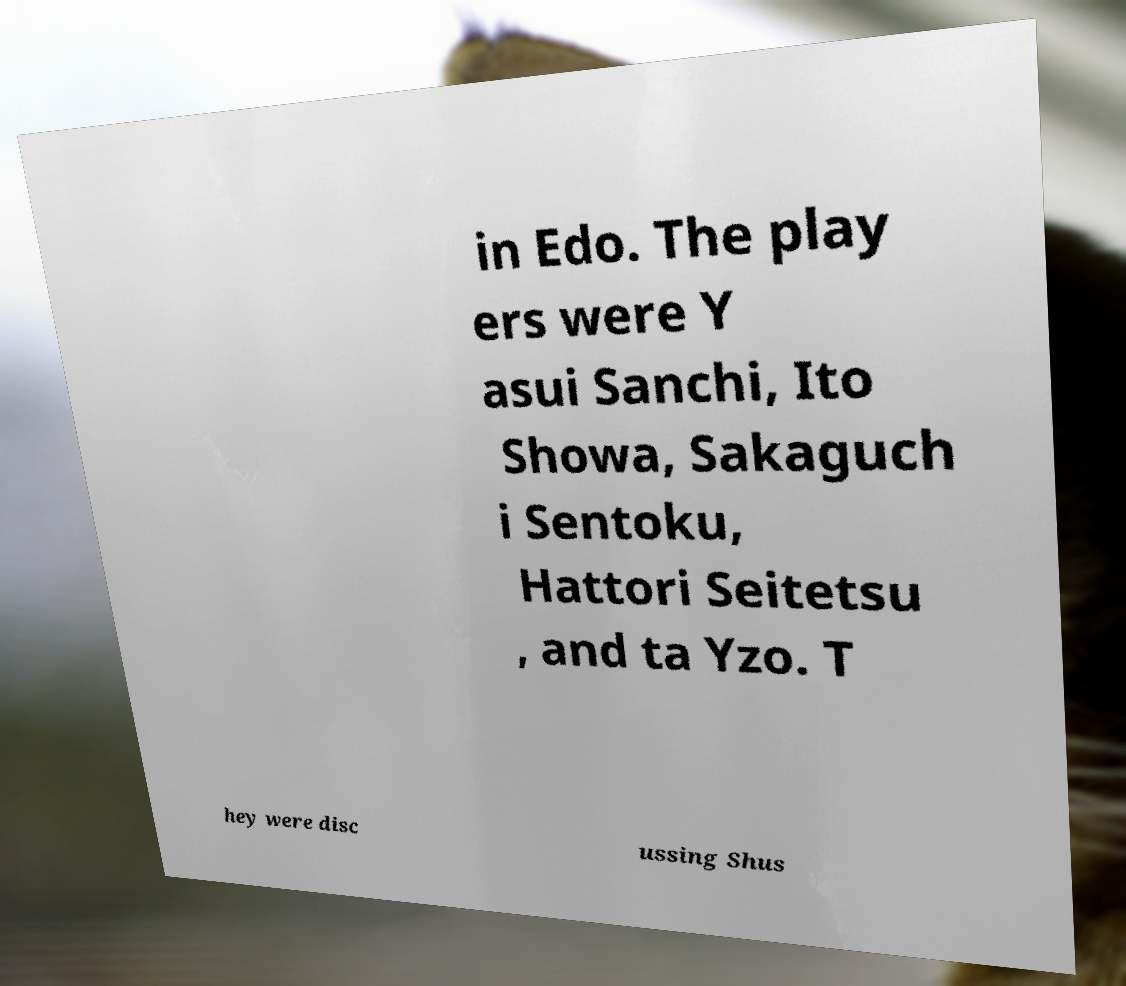Could you assist in decoding the text presented in this image and type it out clearly? in Edo. The play ers were Y asui Sanchi, Ito Showa, Sakaguch i Sentoku, Hattori Seitetsu , and ta Yzo. T hey were disc ussing Shus 